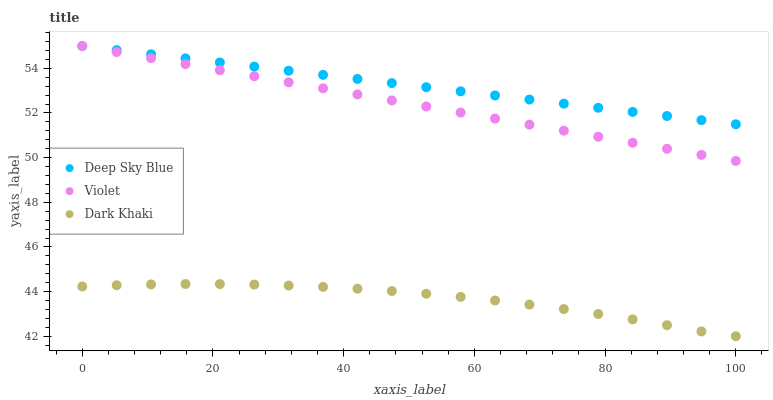Does Dark Khaki have the minimum area under the curve?
Answer yes or no. Yes. Does Deep Sky Blue have the maximum area under the curve?
Answer yes or no. Yes. Does Violet have the minimum area under the curve?
Answer yes or no. No. Does Violet have the maximum area under the curve?
Answer yes or no. No. Is Deep Sky Blue the smoothest?
Answer yes or no. Yes. Is Dark Khaki the roughest?
Answer yes or no. Yes. Is Violet the smoothest?
Answer yes or no. No. Is Violet the roughest?
Answer yes or no. No. Does Dark Khaki have the lowest value?
Answer yes or no. Yes. Does Violet have the lowest value?
Answer yes or no. No. Does Violet have the highest value?
Answer yes or no. Yes. Is Dark Khaki less than Deep Sky Blue?
Answer yes or no. Yes. Is Deep Sky Blue greater than Dark Khaki?
Answer yes or no. Yes. Does Violet intersect Deep Sky Blue?
Answer yes or no. Yes. Is Violet less than Deep Sky Blue?
Answer yes or no. No. Is Violet greater than Deep Sky Blue?
Answer yes or no. No. Does Dark Khaki intersect Deep Sky Blue?
Answer yes or no. No. 